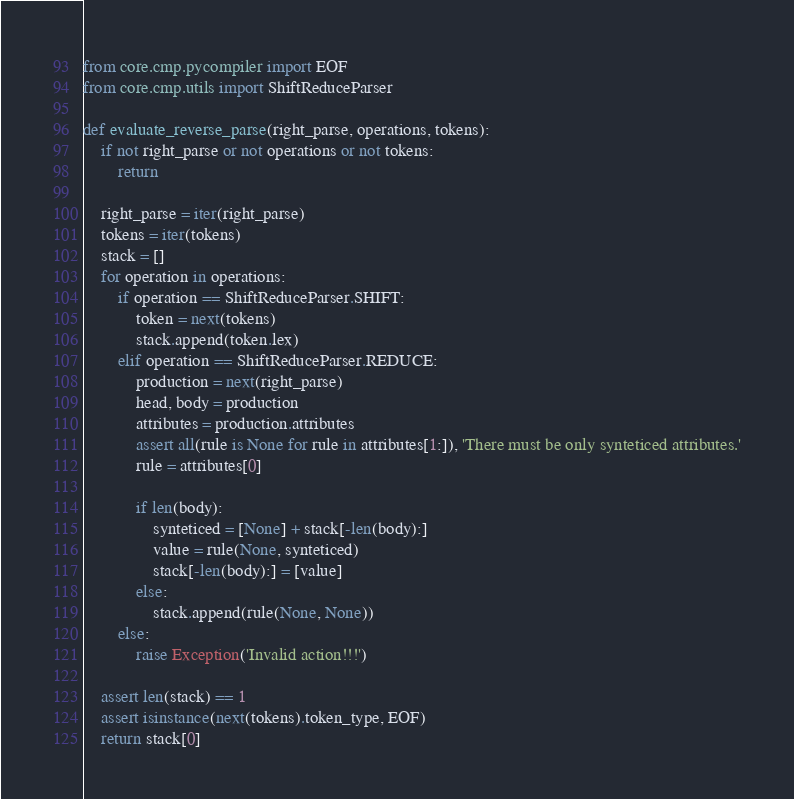<code> <loc_0><loc_0><loc_500><loc_500><_Python_>from core.cmp.pycompiler import EOF
from core.cmp.utils import ShiftReduceParser

def evaluate_reverse_parse(right_parse, operations, tokens):
    if not right_parse or not operations or not tokens:
        return

    right_parse = iter(right_parse)
    tokens = iter(tokens)
    stack = []
    for operation in operations:
        if operation == ShiftReduceParser.SHIFT:
            token = next(tokens)
            stack.append(token.lex)
        elif operation == ShiftReduceParser.REDUCE:
            production = next(right_parse)
            head, body = production
            attributes = production.attributes
            assert all(rule is None for rule in attributes[1:]), 'There must be only synteticed attributes.'
            rule = attributes[0]

            if len(body):
                synteticed = [None] + stack[-len(body):]
                value = rule(None, synteticed)
                stack[-len(body):] = [value]
            else:
                stack.append(rule(None, None))
        else:
            raise Exception('Invalid action!!!')

    assert len(stack) == 1
    assert isinstance(next(tokens).token_type, EOF)
    return stack[0]</code> 